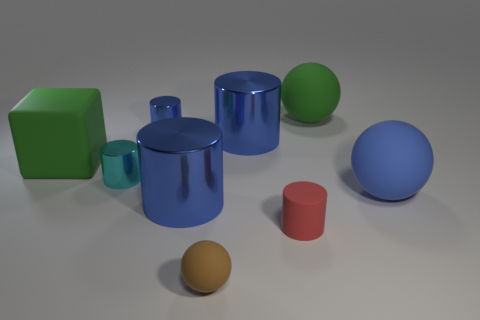How many blue cylinders must be subtracted to get 1 blue cylinders? 2 Subtract all blue blocks. How many blue cylinders are left? 3 Subtract 1 cylinders. How many cylinders are left? 4 Subtract all red cylinders. How many cylinders are left? 4 Subtract all small cyan metal cylinders. How many cylinders are left? 4 Subtract all gray cylinders. Subtract all cyan balls. How many cylinders are left? 5 Add 1 green rubber objects. How many objects exist? 10 Subtract all cylinders. How many objects are left? 4 Add 7 blue rubber balls. How many blue rubber balls exist? 8 Subtract 2 blue cylinders. How many objects are left? 7 